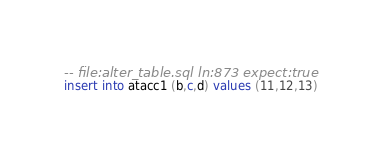<code> <loc_0><loc_0><loc_500><loc_500><_SQL_>-- file:alter_table.sql ln:873 expect:true
insert into atacc1 (b,c,d) values (11,12,13)
</code> 